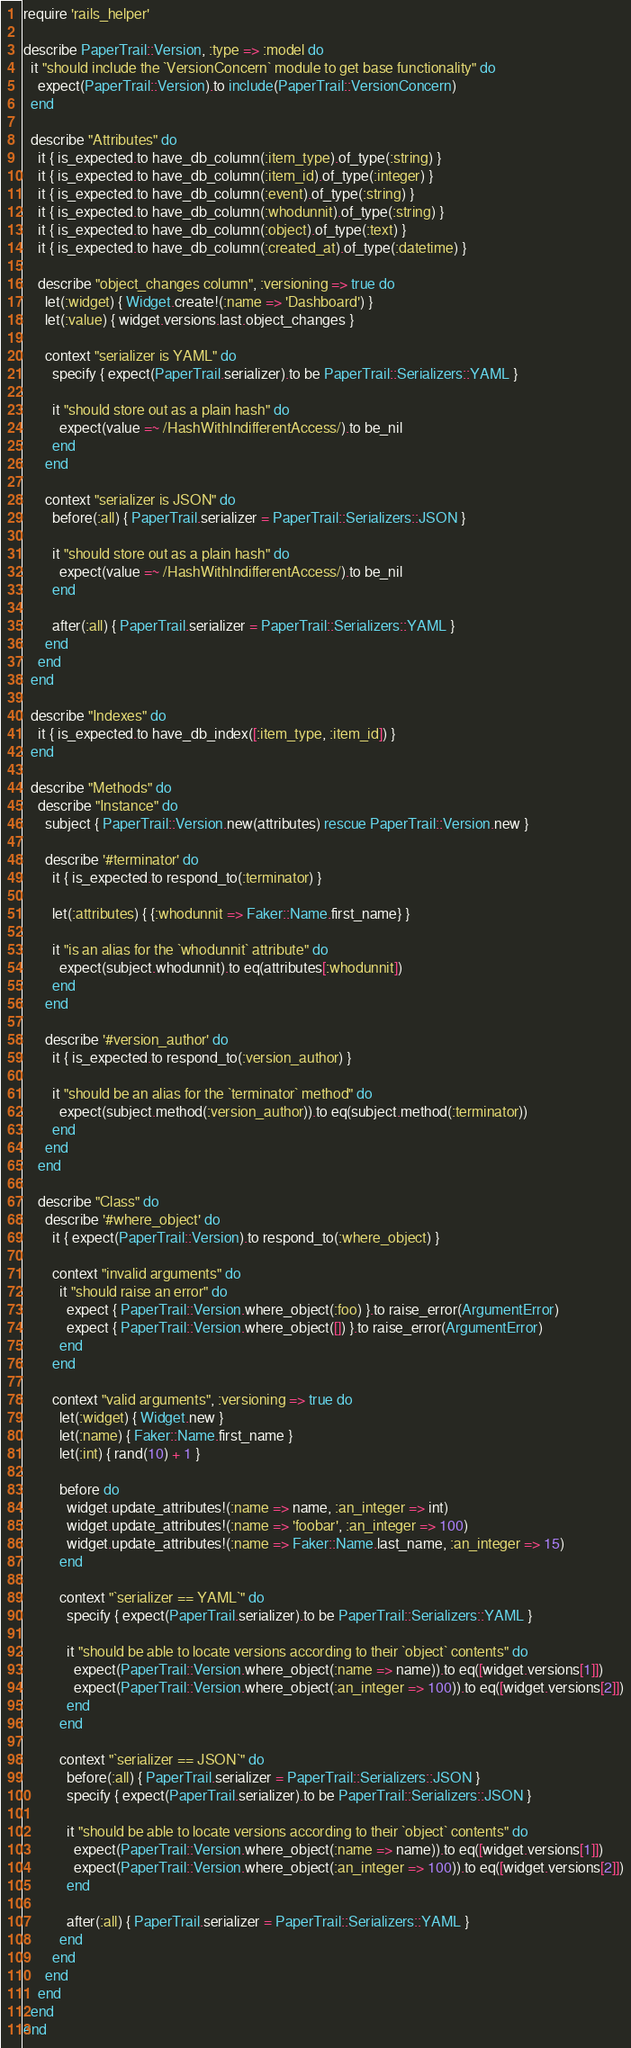<code> <loc_0><loc_0><loc_500><loc_500><_Ruby_>require 'rails_helper'

describe PaperTrail::Version, :type => :model do
  it "should include the `VersionConcern` module to get base functionality" do
    expect(PaperTrail::Version).to include(PaperTrail::VersionConcern)
  end

  describe "Attributes" do
    it { is_expected.to have_db_column(:item_type).of_type(:string) }
    it { is_expected.to have_db_column(:item_id).of_type(:integer) }
    it { is_expected.to have_db_column(:event).of_type(:string) }
    it { is_expected.to have_db_column(:whodunnit).of_type(:string) }
    it { is_expected.to have_db_column(:object).of_type(:text) }
    it { is_expected.to have_db_column(:created_at).of_type(:datetime) }

    describe "object_changes column", :versioning => true do
      let(:widget) { Widget.create!(:name => 'Dashboard') }
      let(:value) { widget.versions.last.object_changes }

      context "serializer is YAML" do
        specify { expect(PaperTrail.serializer).to be PaperTrail::Serializers::YAML }

        it "should store out as a plain hash" do
          expect(value =~ /HashWithIndifferentAccess/).to be_nil
        end
      end

      context "serializer is JSON" do
        before(:all) { PaperTrail.serializer = PaperTrail::Serializers::JSON }

        it "should store out as a plain hash" do
          expect(value =~ /HashWithIndifferentAccess/).to be_nil
        end

        after(:all) { PaperTrail.serializer = PaperTrail::Serializers::YAML }
      end
    end
  end

  describe "Indexes" do
    it { is_expected.to have_db_index([:item_type, :item_id]) }
  end

  describe "Methods" do
    describe "Instance" do
      subject { PaperTrail::Version.new(attributes) rescue PaperTrail::Version.new }

      describe '#terminator' do
        it { is_expected.to respond_to(:terminator) }

        let(:attributes) { {:whodunnit => Faker::Name.first_name} }

        it "is an alias for the `whodunnit` attribute" do
          expect(subject.whodunnit).to eq(attributes[:whodunnit])
        end
      end

      describe '#version_author' do
        it { is_expected.to respond_to(:version_author) }

        it "should be an alias for the `terminator` method" do
          expect(subject.method(:version_author)).to eq(subject.method(:terminator))
        end
      end
    end

    describe "Class" do
      describe '#where_object' do
        it { expect(PaperTrail::Version).to respond_to(:where_object) }

        context "invalid arguments" do
          it "should raise an error" do
            expect { PaperTrail::Version.where_object(:foo) }.to raise_error(ArgumentError)
            expect { PaperTrail::Version.where_object([]) }.to raise_error(ArgumentError)
          end
        end

        context "valid arguments", :versioning => true do
          let(:widget) { Widget.new }
          let(:name) { Faker::Name.first_name }
          let(:int) { rand(10) + 1 }

          before do
            widget.update_attributes!(:name => name, :an_integer => int)
            widget.update_attributes!(:name => 'foobar', :an_integer => 100)
            widget.update_attributes!(:name => Faker::Name.last_name, :an_integer => 15)
          end

          context "`serializer == YAML`" do
            specify { expect(PaperTrail.serializer).to be PaperTrail::Serializers::YAML }

            it "should be able to locate versions according to their `object` contents" do
              expect(PaperTrail::Version.where_object(:name => name)).to eq([widget.versions[1]])
              expect(PaperTrail::Version.where_object(:an_integer => 100)).to eq([widget.versions[2]])
            end
          end

          context "`serializer == JSON`" do
            before(:all) { PaperTrail.serializer = PaperTrail::Serializers::JSON }
            specify { expect(PaperTrail.serializer).to be PaperTrail::Serializers::JSON }

            it "should be able to locate versions according to their `object` contents" do
              expect(PaperTrail::Version.where_object(:name => name)).to eq([widget.versions[1]])
              expect(PaperTrail::Version.where_object(:an_integer => 100)).to eq([widget.versions[2]])
            end

            after(:all) { PaperTrail.serializer = PaperTrail::Serializers::YAML }
          end
        end
      end
    end
  end
end
</code> 